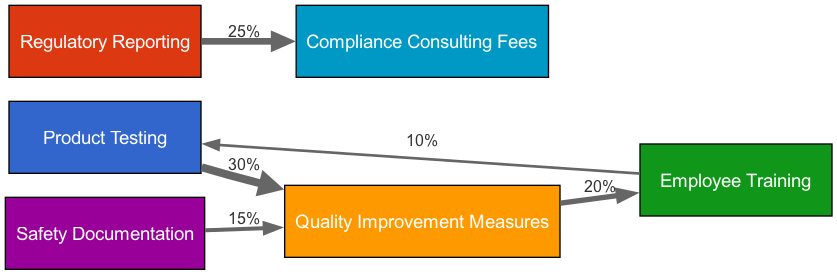What is the total number of nodes in the diagram? The diagram contains six distinct nodes: Product Testing, Regulatory Reporting, Quality Improvement Measures, Employee Training, Safety Documentation, and Compliance Consulting Fees. Therefore, counting these gives a total of six nodes.
Answer: 6 Which node has the largest outgoing flow? The node "Product Testing" connects to "Quality Improvement Measures" with an outgoing flow of 30%. Comparing this to the outgoing flows of other nodes, this is the largest flow.
Answer: Product Testing What is the percentage flow from Regulatory Reporting to Compliance Consulting Fees? The flow from Regulatory Reporting to Compliance Consulting Fees is specifically labeled at 25%. There are no other flows from Reporting, making this value clear and direct.
Answer: 25% How much percentage of Quality Improvement Measures comes from Documentation? The flow between "Documentation" and "Quality Improvement Measures" is indicated as 15%. This is a direct observation of the flow linking these two nodes.
Answer: 15% What is the flow from Training back to Testing? The flow from "Training" to "Product Testing" is noted at 10%. This means that a portion of resources allocated for training is redirected to testing, quantifiable as 10%.
Answer: 10% Which two nodes have a direct connection showing a flow of 20%? The nodes "Quality Improvement Measures" and "Employee Training" are connected with a flow of 20%. This connection indicates that Quality Improvement measures lead to a percentage allocation towards Training.
Answer: Quality Improvement Measures and Employee Training Which node connects to Compliance Consulting Fees? "Regulatory Reporting" connects to "Compliance Consulting Fees" with a flow of 25%. This relationship indicates where resources are allocated regarding compliance consulting.
Answer: Regulatory Reporting What is the combined flow percentage that Quality Improvement Measures receives? Quality Improvement Measures receives a total of 30% from Testing and 15% from Documentation, totaling 45%. This is calculated by adding the direct incoming flows to that node.
Answer: 45% How does Employee Training relate to Testing in terms of flow direction? Employee Training has a flow back to Product Testing, indicating a reverse flow of 10%. This shows the interconnection and resource allocation in an opposite direction from Training to Testing.
Answer: Employee Training to Testing 